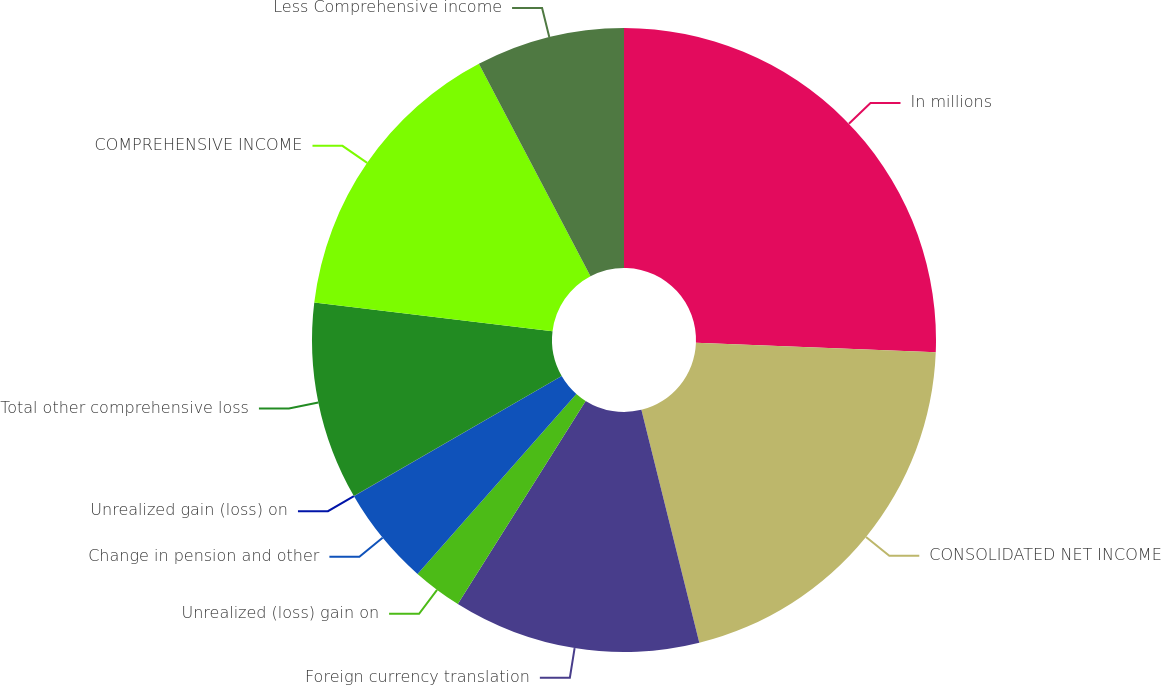Convert chart. <chart><loc_0><loc_0><loc_500><loc_500><pie_chart><fcel>In millions<fcel>CONSOLIDATED NET INCOME<fcel>Foreign currency translation<fcel>Unrealized (loss) gain on<fcel>Change in pension and other<fcel>Unrealized gain (loss) on<fcel>Total other comprehensive loss<fcel>COMPREHENSIVE INCOME<fcel>Less Comprehensive income<nl><fcel>25.62%<fcel>20.5%<fcel>12.82%<fcel>2.57%<fcel>5.14%<fcel>0.01%<fcel>10.26%<fcel>15.38%<fcel>7.7%<nl></chart> 